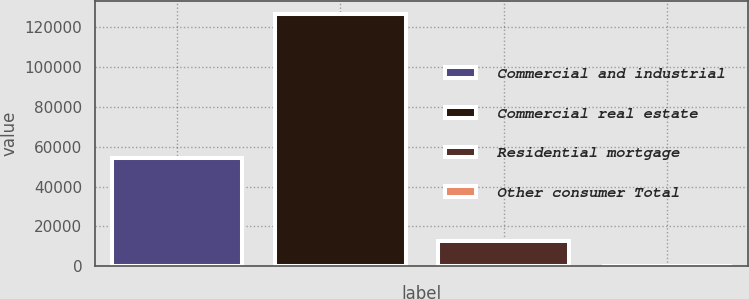<chart> <loc_0><loc_0><loc_500><loc_500><bar_chart><fcel>Commercial and industrial<fcel>Commercial real estate<fcel>Residential mortgage<fcel>Other consumer Total<nl><fcel>54472<fcel>126923<fcel>12818.3<fcel>140<nl></chart> 